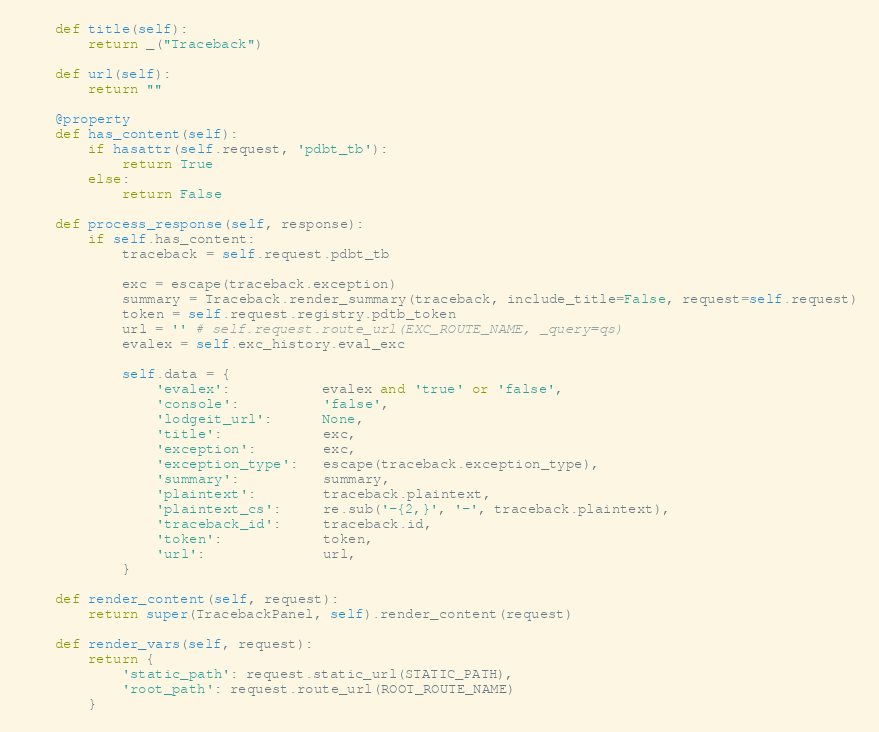<code> <loc_0><loc_0><loc_500><loc_500><_Python_>
    def title(self):
        return _("Traceback")

    def url(self):
        return ""

    @property
    def has_content(self):
        if hasattr(self.request, 'pdbt_tb'):
            return True
        else:
            return False

    def process_response(self, response):
        if self.has_content:
            traceback = self.request.pdbt_tb

            exc = escape(traceback.exception)
            summary = Traceback.render_summary(traceback, include_title=False, request=self.request)
            token = self.request.registry.pdtb_token
            url = '' # self.request.route_url(EXC_ROUTE_NAME, _query=qs)
            evalex = self.exc_history.eval_exc

            self.data = {
                'evalex':           evalex and 'true' or 'false',
                'console':          'false',
                'lodgeit_url':      None,
                'title':            exc,
                'exception':        exc,
                'exception_type':   escape(traceback.exception_type),
                'summary':          summary,
                'plaintext':        traceback.plaintext,
                'plaintext_cs':     re.sub('-{2,}', '-', traceback.plaintext),
                'traceback_id':     traceback.id,
                'token':            token,
                'url':              url,
            }

    def render_content(self, request):
        return super(TracebackPanel, self).render_content(request)

    def render_vars(self, request):
        return {
            'static_path': request.static_url(STATIC_PATH),
            'root_path': request.route_url(ROOT_ROUTE_NAME)
        }
</code> 